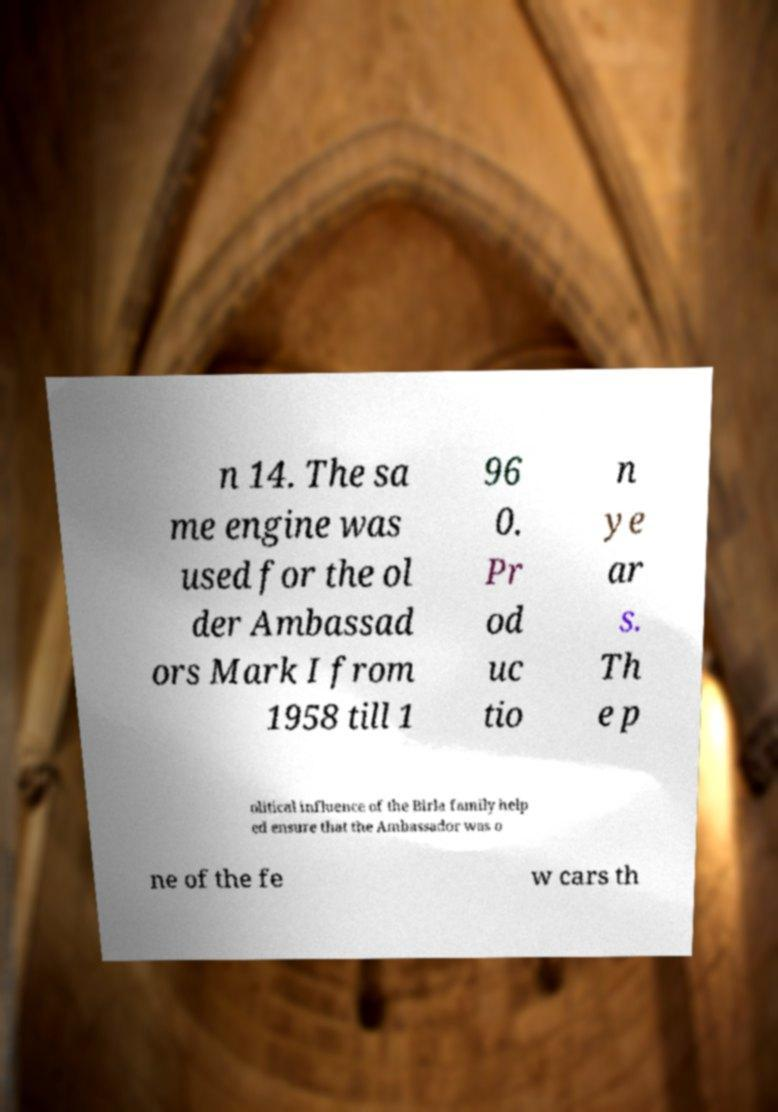Could you extract and type out the text from this image? n 14. The sa me engine was used for the ol der Ambassad ors Mark I from 1958 till 1 96 0. Pr od uc tio n ye ar s. Th e p olitical influence of the Birla family help ed ensure that the Ambassador was o ne of the fe w cars th 